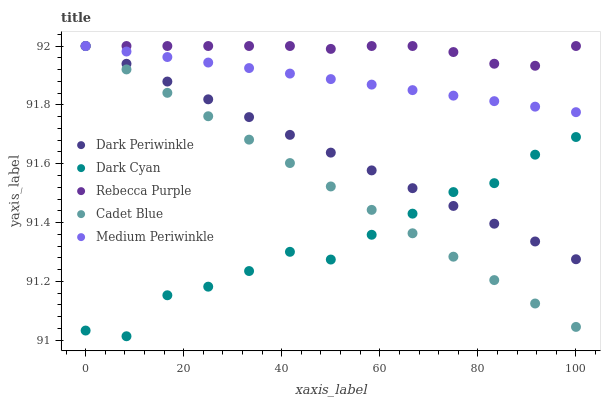Does Dark Cyan have the minimum area under the curve?
Answer yes or no. Yes. Does Rebecca Purple have the maximum area under the curve?
Answer yes or no. Yes. Does Cadet Blue have the minimum area under the curve?
Answer yes or no. No. Does Cadet Blue have the maximum area under the curve?
Answer yes or no. No. Is Dark Periwinkle the smoothest?
Answer yes or no. Yes. Is Dark Cyan the roughest?
Answer yes or no. Yes. Is Cadet Blue the smoothest?
Answer yes or no. No. Is Cadet Blue the roughest?
Answer yes or no. No. Does Dark Cyan have the lowest value?
Answer yes or no. Yes. Does Cadet Blue have the lowest value?
Answer yes or no. No. Does Rebecca Purple have the highest value?
Answer yes or no. Yes. Is Dark Cyan less than Rebecca Purple?
Answer yes or no. Yes. Is Rebecca Purple greater than Dark Cyan?
Answer yes or no. Yes. Does Dark Periwinkle intersect Medium Periwinkle?
Answer yes or no. Yes. Is Dark Periwinkle less than Medium Periwinkle?
Answer yes or no. No. Is Dark Periwinkle greater than Medium Periwinkle?
Answer yes or no. No. Does Dark Cyan intersect Rebecca Purple?
Answer yes or no. No. 